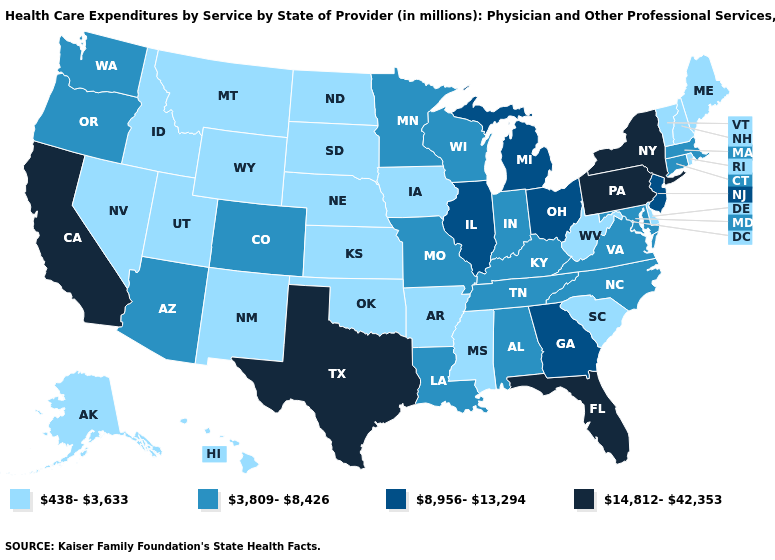Does Kansas have the highest value in the MidWest?
Short answer required. No. Which states have the lowest value in the USA?
Be succinct. Alaska, Arkansas, Delaware, Hawaii, Idaho, Iowa, Kansas, Maine, Mississippi, Montana, Nebraska, Nevada, New Hampshire, New Mexico, North Dakota, Oklahoma, Rhode Island, South Carolina, South Dakota, Utah, Vermont, West Virginia, Wyoming. Does New York have the highest value in the Northeast?
Quick response, please. Yes. What is the value of Mississippi?
Concise answer only. 438-3,633. Among the states that border Connecticut , which have the highest value?
Concise answer only. New York. Is the legend a continuous bar?
Keep it brief. No. What is the value of Montana?
Give a very brief answer. 438-3,633. Does New Hampshire have the highest value in the Northeast?
Keep it brief. No. What is the lowest value in the USA?
Be succinct. 438-3,633. Does Kansas have the same value as Idaho?
Give a very brief answer. Yes. Which states hav the highest value in the South?
Concise answer only. Florida, Texas. Which states have the lowest value in the South?
Answer briefly. Arkansas, Delaware, Mississippi, Oklahoma, South Carolina, West Virginia. What is the value of Kentucky?
Quick response, please. 3,809-8,426. Among the states that border Vermont , which have the highest value?
Answer briefly. New York. Name the states that have a value in the range 3,809-8,426?
Concise answer only. Alabama, Arizona, Colorado, Connecticut, Indiana, Kentucky, Louisiana, Maryland, Massachusetts, Minnesota, Missouri, North Carolina, Oregon, Tennessee, Virginia, Washington, Wisconsin. 